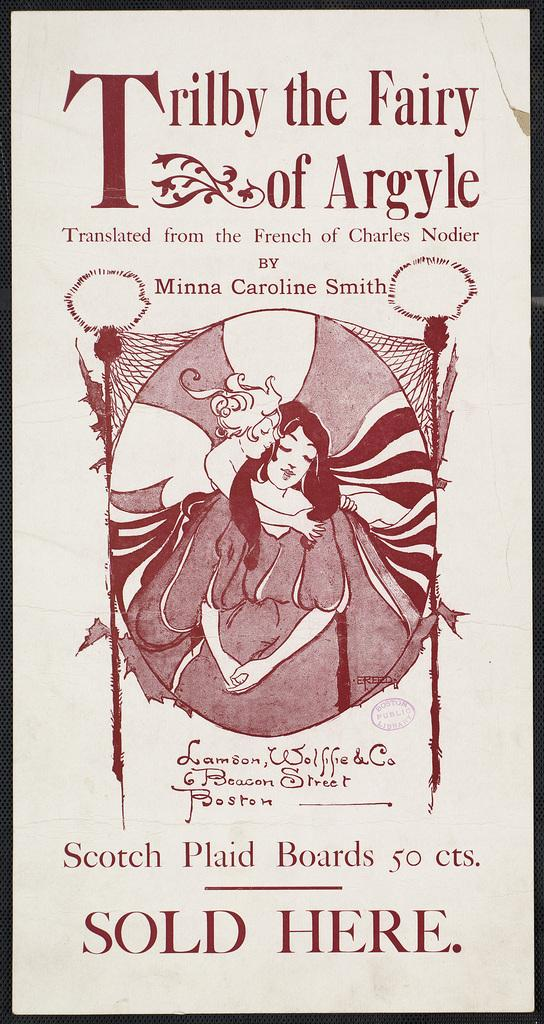<image>
Offer a succinct explanation of the picture presented. An old advertisement says that scotch plaid boards are sold there. 